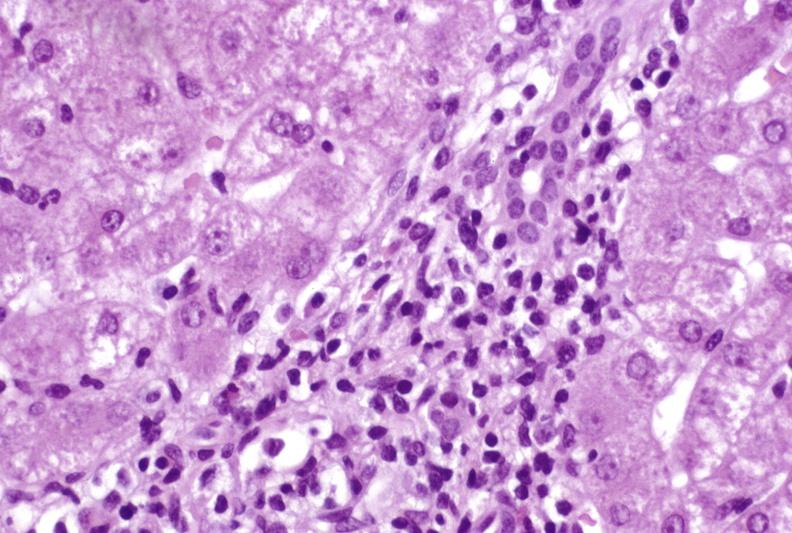s hepatobiliary present?
Answer the question using a single word or phrase. Yes 